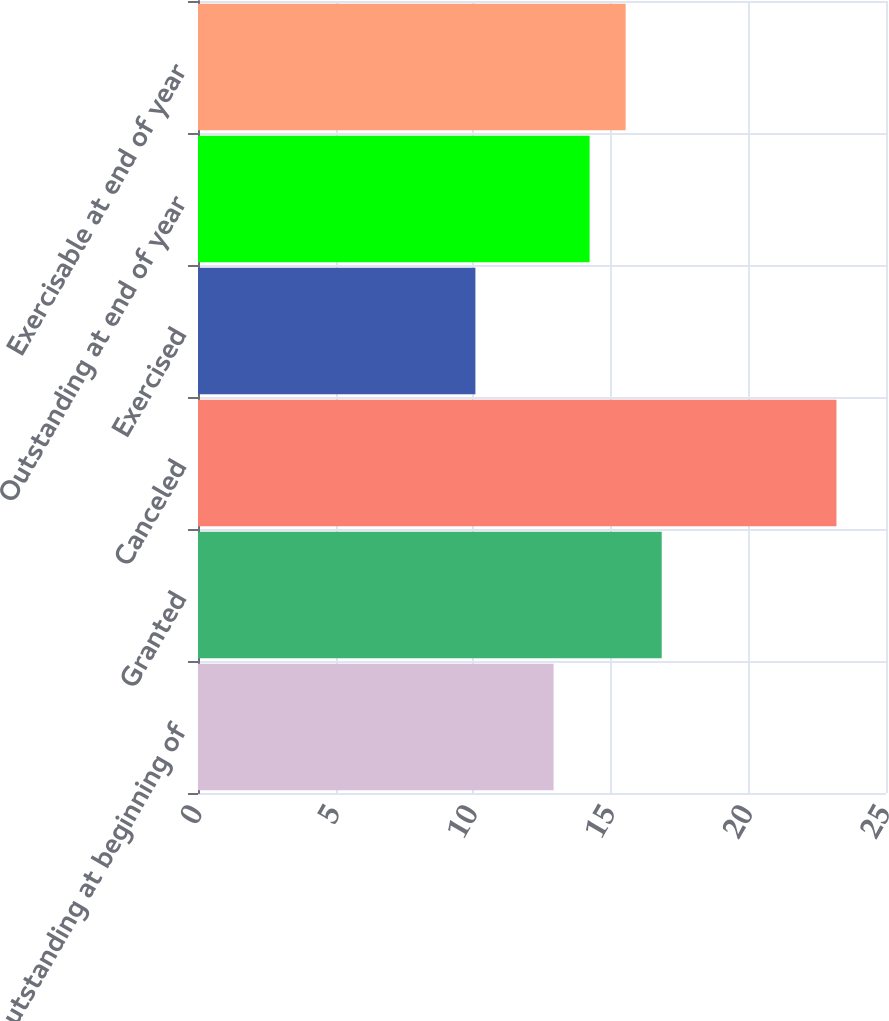Convert chart. <chart><loc_0><loc_0><loc_500><loc_500><bar_chart><fcel>Outstanding at beginning of<fcel>Granted<fcel>Canceled<fcel>Exercised<fcel>Outstanding at end of year<fcel>Exercisable at end of year<nl><fcel>12.92<fcel>16.85<fcel>23.2<fcel>10.08<fcel>14.23<fcel>15.54<nl></chart> 